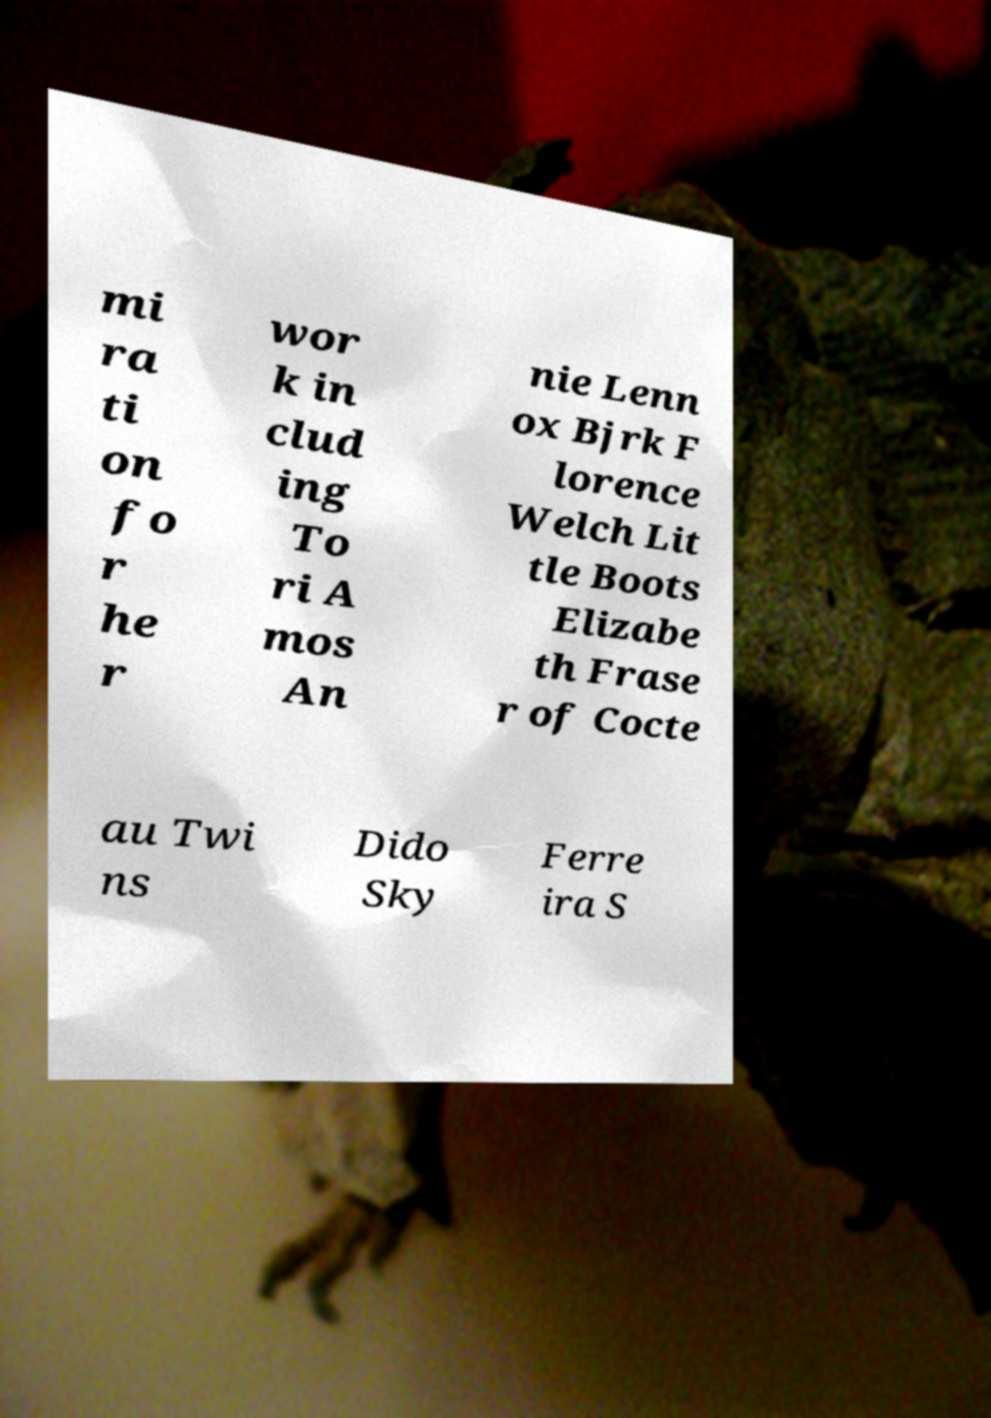Can you accurately transcribe the text from the provided image for me? mi ra ti on fo r he r wor k in clud ing To ri A mos An nie Lenn ox Bjrk F lorence Welch Lit tle Boots Elizabe th Frase r of Cocte au Twi ns Dido Sky Ferre ira S 